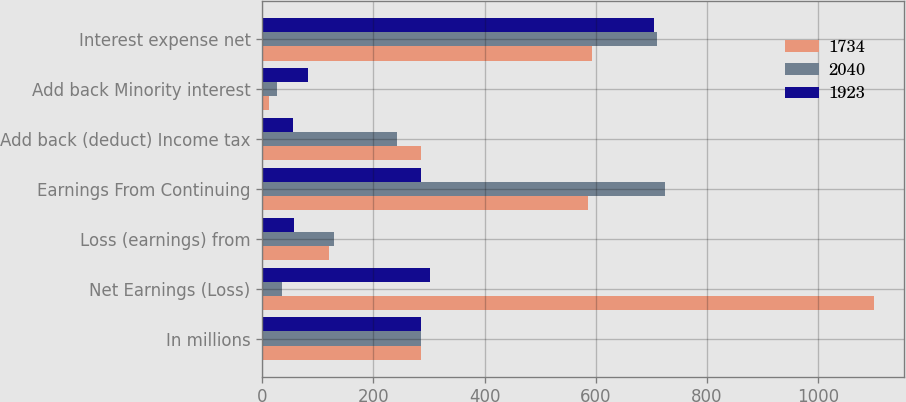Convert chart to OTSL. <chart><loc_0><loc_0><loc_500><loc_500><stacked_bar_chart><ecel><fcel>In millions<fcel>Net Earnings (Loss)<fcel>Loss (earnings) from<fcel>Earnings From Continuing<fcel>Add back (deduct) Income tax<fcel>Add back Minority interest<fcel>Interest expense net<nl><fcel>1734<fcel>285<fcel>1100<fcel>120<fcel>586<fcel>285<fcel>12<fcel>593<nl><fcel>2040<fcel>285<fcel>35<fcel>130<fcel>724<fcel>242<fcel>26<fcel>710<nl><fcel>1923<fcel>285<fcel>302<fcel>57<fcel>285<fcel>56<fcel>83<fcel>705<nl></chart> 